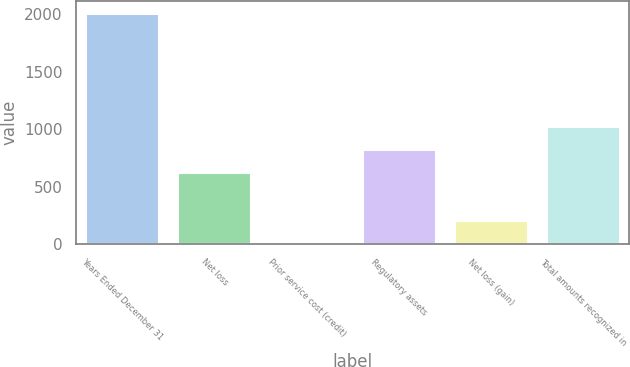Convert chart to OTSL. <chart><loc_0><loc_0><loc_500><loc_500><bar_chart><fcel>Years Ended December 31<fcel>Net loss<fcel>Prior service cost (credit)<fcel>Regulatory assets<fcel>Net loss (gain)<fcel>Total amounts recognized in<nl><fcel>2013<fcel>625<fcel>9<fcel>825.4<fcel>209.4<fcel>1025.8<nl></chart> 